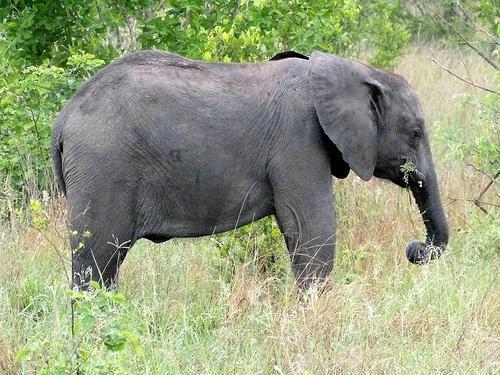How many elephants?
Give a very brief answer. 1. How many animals?
Give a very brief answer. 1. 